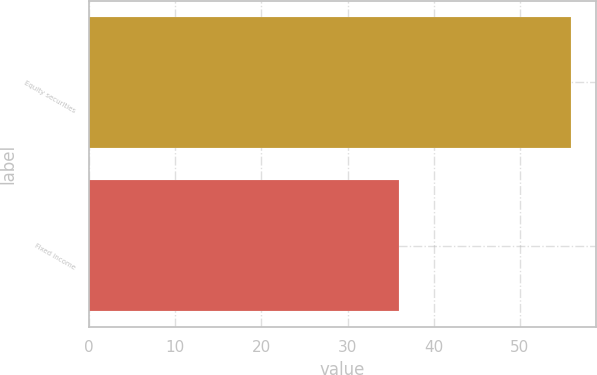Convert chart to OTSL. <chart><loc_0><loc_0><loc_500><loc_500><bar_chart><fcel>Equity securities<fcel>Fixed income<nl><fcel>56<fcel>36<nl></chart> 